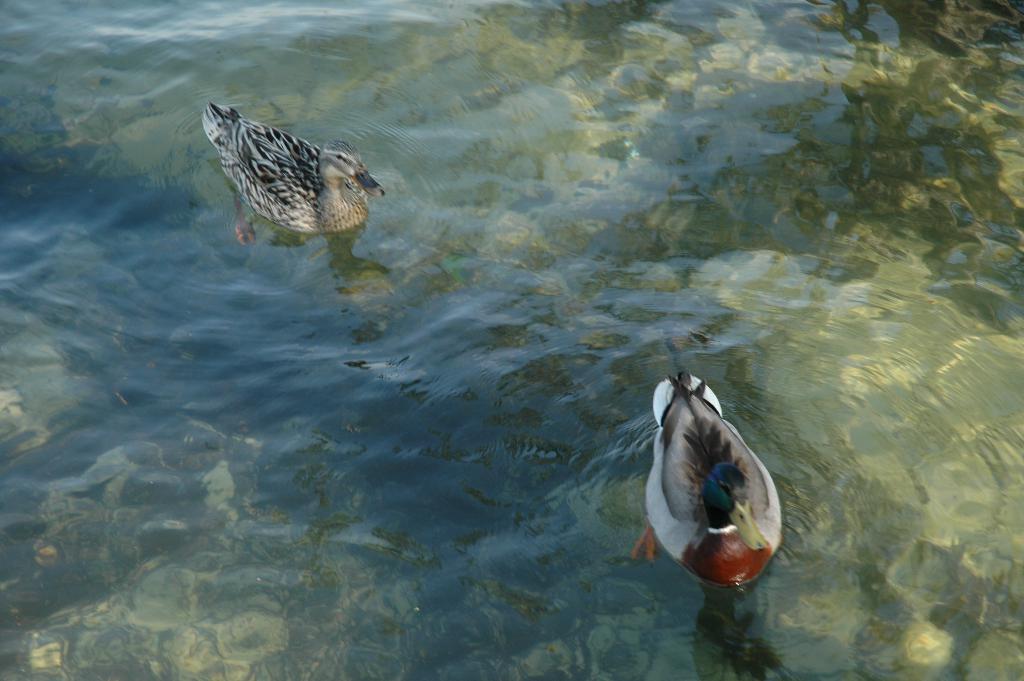How would you summarize this image in a sentence or two? In this image there is water, there are ducks in the water. 